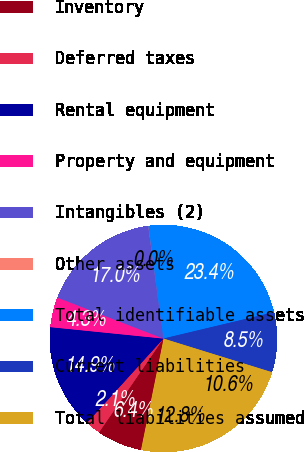<chart> <loc_0><loc_0><loc_500><loc_500><pie_chart><fcel>Accounts receivable net of<fcel>Inventory<fcel>Deferred taxes<fcel>Rental equipment<fcel>Property and equipment<fcel>Intangibles (2)<fcel>Other assets<fcel>Total identifiable assets<fcel>Current liabilities<fcel>Total liabilities assumed<nl><fcel>12.76%<fcel>6.39%<fcel>2.15%<fcel>14.88%<fcel>4.27%<fcel>17.0%<fcel>0.03%<fcel>23.37%<fcel>8.51%<fcel>10.64%<nl></chart> 